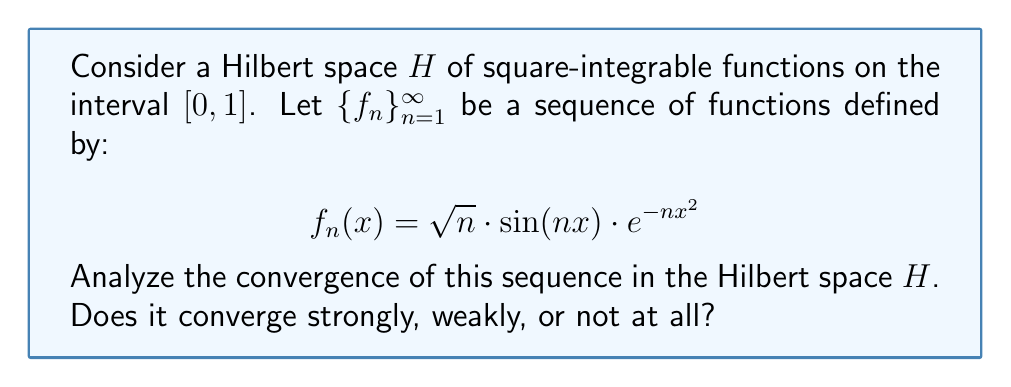Give your solution to this math problem. To analyze the convergence of the sequence $\{f_n\}_{n=1}^{\infty}$ in the Hilbert space $H$, we need to consider both strong and weak convergence.

1. Strong convergence:
For strong convergence, we need to show that $\|f_n - f\| \to 0$ as $n \to \infty$ for some $f \in H$. Let's examine the norm of $f_n$:

$$\|f_n\|^2 = \int_0^1 |f_n(x)|^2 dx = \int_0^1 n \sin^2(nx) e^{-2nx^2} dx$$

Using the substitution $u = nx$, we get:

$$\|f_n\|^2 = \int_0^n \sin^2(u) e^{-2u^2/n} \frac{du}{n}$$

As $n \to \infty$, this integral approaches:

$$\lim_{n \to \infty} \|f_n\|^2 = \int_0^{\infty} \sin^2(u) \cdot 0 \, du = 0$$

This shows that $\|f_n\| \to 0$ as $n \to \infty$. Therefore, the sequence converges strongly to the zero function.

2. Weak convergence:
Since we've shown strong convergence to the zero function, weak convergence also holds. For any $g \in H$:

$$\langle f_n, g \rangle = \int_0^1 f_n(x) \overline{g(x)} dx \to 0 \text{ as } n \to \infty$$

This is because $f_n \to 0$ strongly, and $g$ is fixed.

In conclusion, the sequence $\{f_n\}_{n=1}^{\infty}$ converges both strongly and weakly to the zero function in the Hilbert space $H$.
Answer: The sequence $\{f_n\}_{n=1}^{\infty}$ converges strongly (and consequently, weakly) to the zero function in the Hilbert space $H$. 